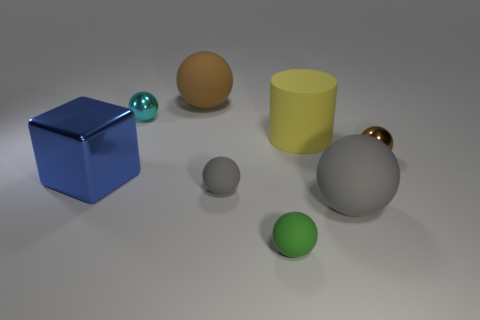Subtract all cyan balls. How many balls are left? 5 Subtract all large brown balls. How many balls are left? 5 Subtract all red balls. Subtract all gray cubes. How many balls are left? 6 Add 1 tiny green spheres. How many objects exist? 9 Subtract all cubes. How many objects are left? 7 Subtract all big brown things. Subtract all tiny metallic things. How many objects are left? 5 Add 2 small gray spheres. How many small gray spheres are left? 3 Add 5 yellow objects. How many yellow objects exist? 6 Subtract 0 cyan blocks. How many objects are left? 8 